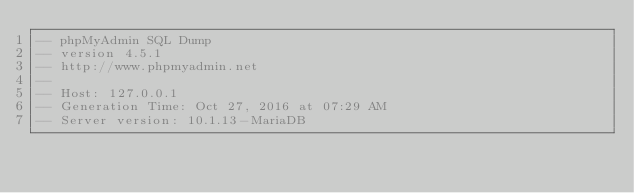Convert code to text. <code><loc_0><loc_0><loc_500><loc_500><_SQL_>-- phpMyAdmin SQL Dump
-- version 4.5.1
-- http://www.phpmyadmin.net
--
-- Host: 127.0.0.1
-- Generation Time: Oct 27, 2016 at 07:29 AM
-- Server version: 10.1.13-MariaDB</code> 